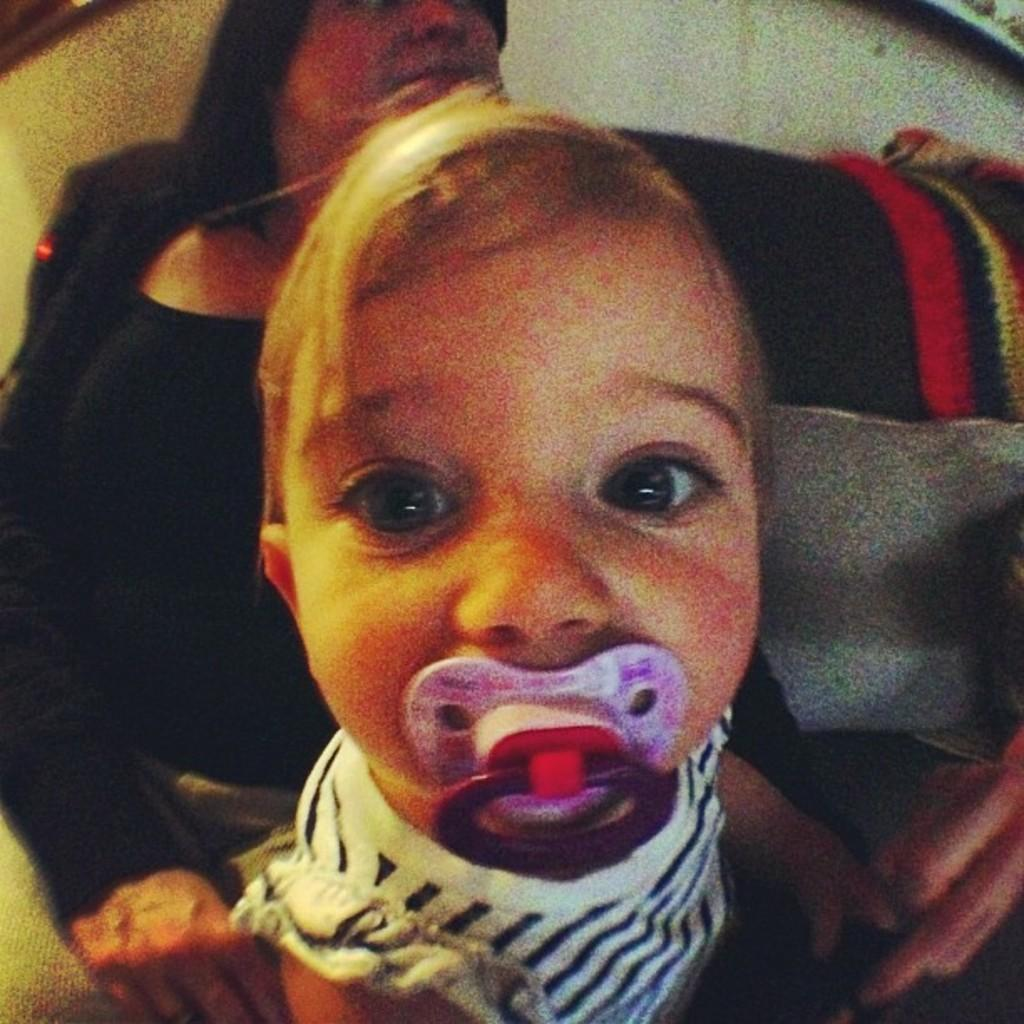What is the main subject in the foreground of the image? There is a child in the foreground of the image. Can you describe the person in the background of the image? There is a person sitting in the background of the image. What type of metal is the ant carrying in the drawer in the image? There is no ant or drawer present in the image; it only features a child in the foreground and a person sitting in the background. 